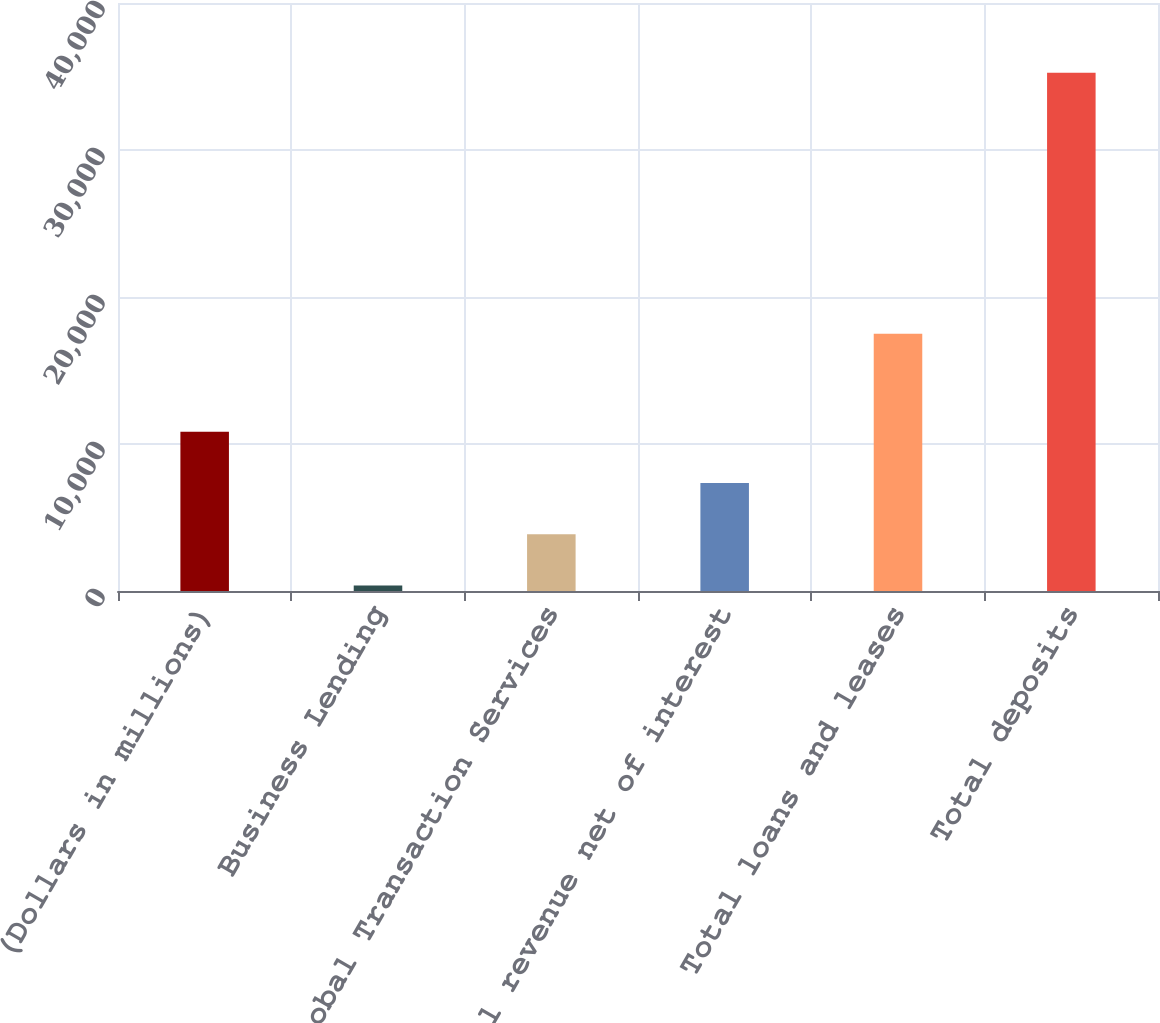Convert chart to OTSL. <chart><loc_0><loc_0><loc_500><loc_500><bar_chart><fcel>(Dollars in millions)<fcel>Business Lending<fcel>Global Transaction Services<fcel>Total revenue net of interest<fcel>Total loans and leases<fcel>Total deposits<nl><fcel>10840<fcel>376<fcel>3864<fcel>7352<fcel>17506<fcel>35256<nl></chart> 